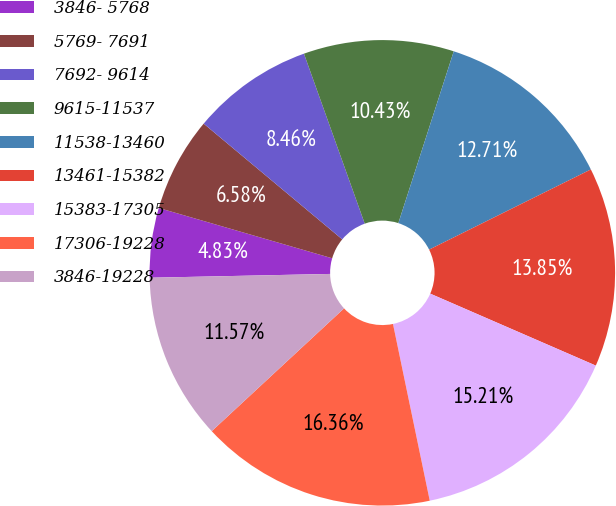Convert chart to OTSL. <chart><loc_0><loc_0><loc_500><loc_500><pie_chart><fcel>3846- 5768<fcel>5769- 7691<fcel>7692- 9614<fcel>9615-11537<fcel>11538-13460<fcel>13461-15382<fcel>15383-17305<fcel>17306-19228<fcel>3846-19228<nl><fcel>4.83%<fcel>6.58%<fcel>8.46%<fcel>10.43%<fcel>12.71%<fcel>13.85%<fcel>15.21%<fcel>16.36%<fcel>11.57%<nl></chart> 